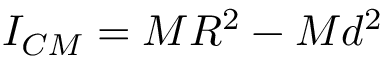Convert formula to latex. <formula><loc_0><loc_0><loc_500><loc_500>I _ { C M } = M R ^ { 2 } - M d ^ { 2 }</formula> 